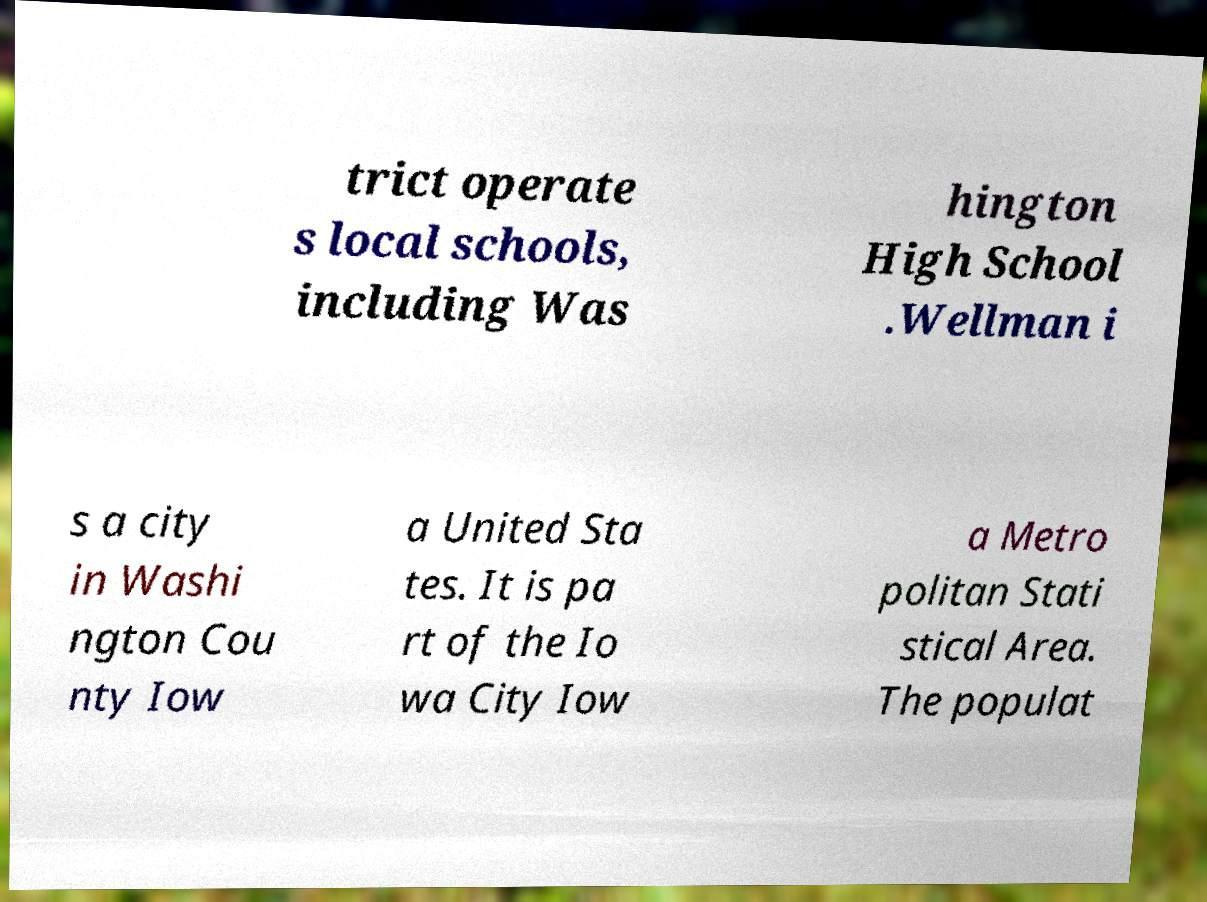Can you accurately transcribe the text from the provided image for me? trict operate s local schools, including Was hington High School .Wellman i s a city in Washi ngton Cou nty Iow a United Sta tes. It is pa rt of the Io wa City Iow a Metro politan Stati stical Area. The populat 